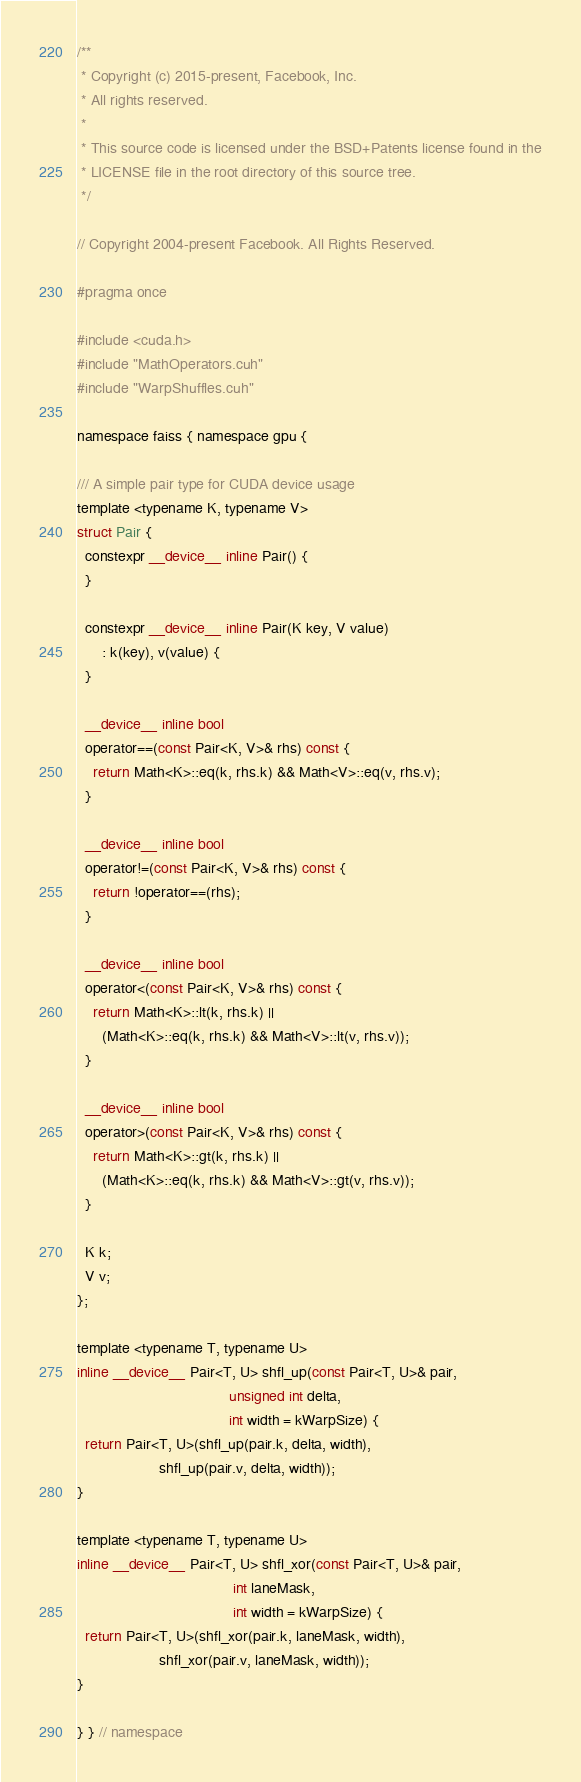<code> <loc_0><loc_0><loc_500><loc_500><_Cuda_>/**
 * Copyright (c) 2015-present, Facebook, Inc.
 * All rights reserved.
 *
 * This source code is licensed under the BSD+Patents license found in the
 * LICENSE file in the root directory of this source tree.
 */

// Copyright 2004-present Facebook. All Rights Reserved.

#pragma once

#include <cuda.h>
#include "MathOperators.cuh"
#include "WarpShuffles.cuh"

namespace faiss { namespace gpu {

/// A simple pair type for CUDA device usage
template <typename K, typename V>
struct Pair {
  constexpr __device__ inline Pair() {
  }

  constexpr __device__ inline Pair(K key, V value)
      : k(key), v(value) {
  }

  __device__ inline bool
  operator==(const Pair<K, V>& rhs) const {
    return Math<K>::eq(k, rhs.k) && Math<V>::eq(v, rhs.v);
  }

  __device__ inline bool
  operator!=(const Pair<K, V>& rhs) const {
    return !operator==(rhs);
  }

  __device__ inline bool
  operator<(const Pair<K, V>& rhs) const {
    return Math<K>::lt(k, rhs.k) ||
      (Math<K>::eq(k, rhs.k) && Math<V>::lt(v, rhs.v));
  }

  __device__ inline bool
  operator>(const Pair<K, V>& rhs) const {
    return Math<K>::gt(k, rhs.k) ||
      (Math<K>::eq(k, rhs.k) && Math<V>::gt(v, rhs.v));
  }

  K k;
  V v;
};

template <typename T, typename U>
inline __device__ Pair<T, U> shfl_up(const Pair<T, U>& pair,
                                     unsigned int delta,
                                     int width = kWarpSize) {
  return Pair<T, U>(shfl_up(pair.k, delta, width),
                    shfl_up(pair.v, delta, width));
}

template <typename T, typename U>
inline __device__ Pair<T, U> shfl_xor(const Pair<T, U>& pair,
                                      int laneMask,
                                      int width = kWarpSize) {
  return Pair<T, U>(shfl_xor(pair.k, laneMask, width),
                    shfl_xor(pair.v, laneMask, width));
}

} } // namespace
</code> 